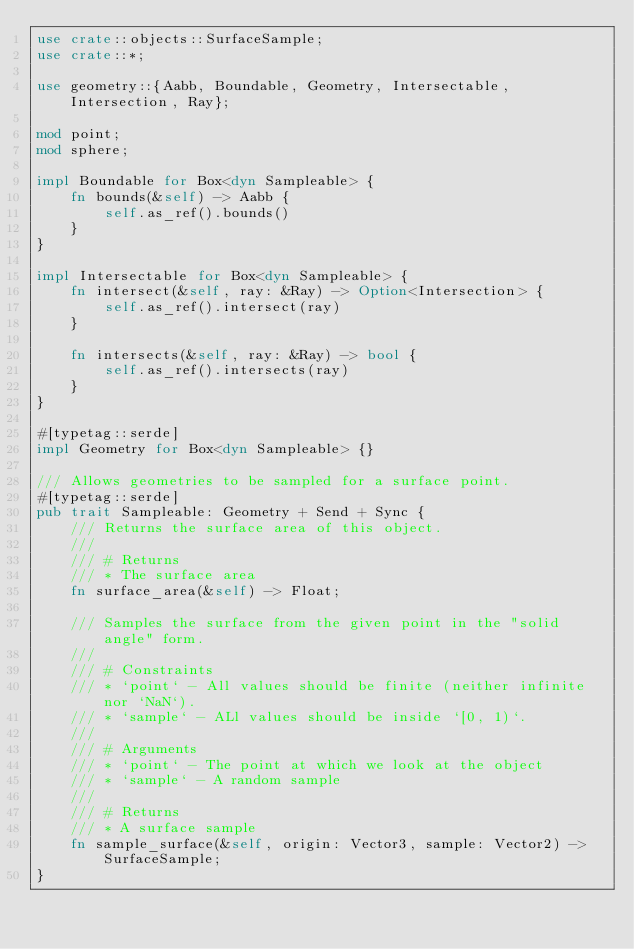Convert code to text. <code><loc_0><loc_0><loc_500><loc_500><_Rust_>use crate::objects::SurfaceSample;
use crate::*;

use geometry::{Aabb, Boundable, Geometry, Intersectable, Intersection, Ray};

mod point;
mod sphere;

impl Boundable for Box<dyn Sampleable> {
    fn bounds(&self) -> Aabb {
        self.as_ref().bounds()
    }
}

impl Intersectable for Box<dyn Sampleable> {
    fn intersect(&self, ray: &Ray) -> Option<Intersection> {
        self.as_ref().intersect(ray)
    }

    fn intersects(&self, ray: &Ray) -> bool {
        self.as_ref().intersects(ray)
    }
}

#[typetag::serde]
impl Geometry for Box<dyn Sampleable> {}

/// Allows geometries to be sampled for a surface point.
#[typetag::serde]
pub trait Sampleable: Geometry + Send + Sync {
    /// Returns the surface area of this object.
    ///
    /// # Returns
    /// * The surface area
    fn surface_area(&self) -> Float;

    /// Samples the surface from the given point in the "solid angle" form.
    ///
    /// # Constraints
    /// * `point` - All values should be finite (neither infinite nor `NaN`).
    /// * `sample` - ALl values should be inside `[0, 1)`.
    ///
    /// # Arguments
    /// * `point` - The point at which we look at the object
    /// * `sample` - A random sample
    ///
    /// # Returns
    /// * A surface sample
    fn sample_surface(&self, origin: Vector3, sample: Vector2) -> SurfaceSample;
}
</code> 